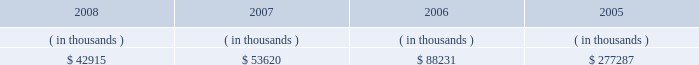System energy resources , inc .
Management's financial discussion and analysis with syndicated bank letters of credit .
In december 2004 , system energy amended these letters of credit and they now expire in may 2009 .
System energy may refinance or redeem debt prior to maturity , to the extent market conditions and interest and dividend rates are favorable .
All debt and common stock issuances by system energy require prior regulatory approval .
Debt issuances are also subject to issuance tests set forth in its bond indentures and other agreements .
System energy has sufficient capacity under these tests to meet its foreseeable capital needs .
System energy has obtained a short-term borrowing authorization from the ferc under which it may borrow , through march 31 , 2010 , up to the aggregate amount , at any one time outstanding , of $ 200 million .
See note 4 to the financial statements for further discussion of system energy's short-term borrowing limits .
System energy has also obtained an order from the ferc authorizing long-term securities issuances .
The current long- term authorization extends through june 2009 .
System energy's receivables from the money pool were as follows as of december 31 for each of the following years: .
In may 2007 , $ 22.5 million of system energy's receivable from the money pool was replaced by a note receivable from entergy new orleans .
See note 4 to the financial statements for a description of the money pool .
Nuclear matters system energy owns and operates grand gulf .
System energy is , therefore , subject to the risks related to owning and operating a nuclear plant .
These include risks from the use , storage , handling and disposal of high-level and low-level radioactive materials , regulatory requirement changes , including changes resulting from events at other plants , limitations on the amounts and types of insurance commercially available for losses in connection with nuclear operations , and technological and financial uncertainties related to decommissioning nuclear plants at the end of their licensed lives , including the sufficiency of funds in decommissioning trusts .
In the event of an unanticipated early shutdown of grand gulf , system energy may be required to provide additional funds or credit support to satisfy regulatory requirements for decommissioning .
Environmental risks system energy's facilities and operations are subject to regulation by various governmental authorities having jurisdiction over air quality , water quality , control of toxic substances and hazardous and solid wastes , and other environmental matters .
Management believes that system energy is in substantial compliance with environmental regulations currently applicable to its facilities and operations .
Because environmental regulations are subject to change , future compliance costs cannot be precisely estimated .
Critical accounting estimates the preparation of system energy's financial statements in conformity with generally accepted accounting principles requires management to apply appropriate accounting policies and to make estimates and judgments that .
How is cash flow of system energy affected by the change in balance of money pool from 2007 to 2008? 
Computations: (53620 - 42915)
Answer: 10705.0. 